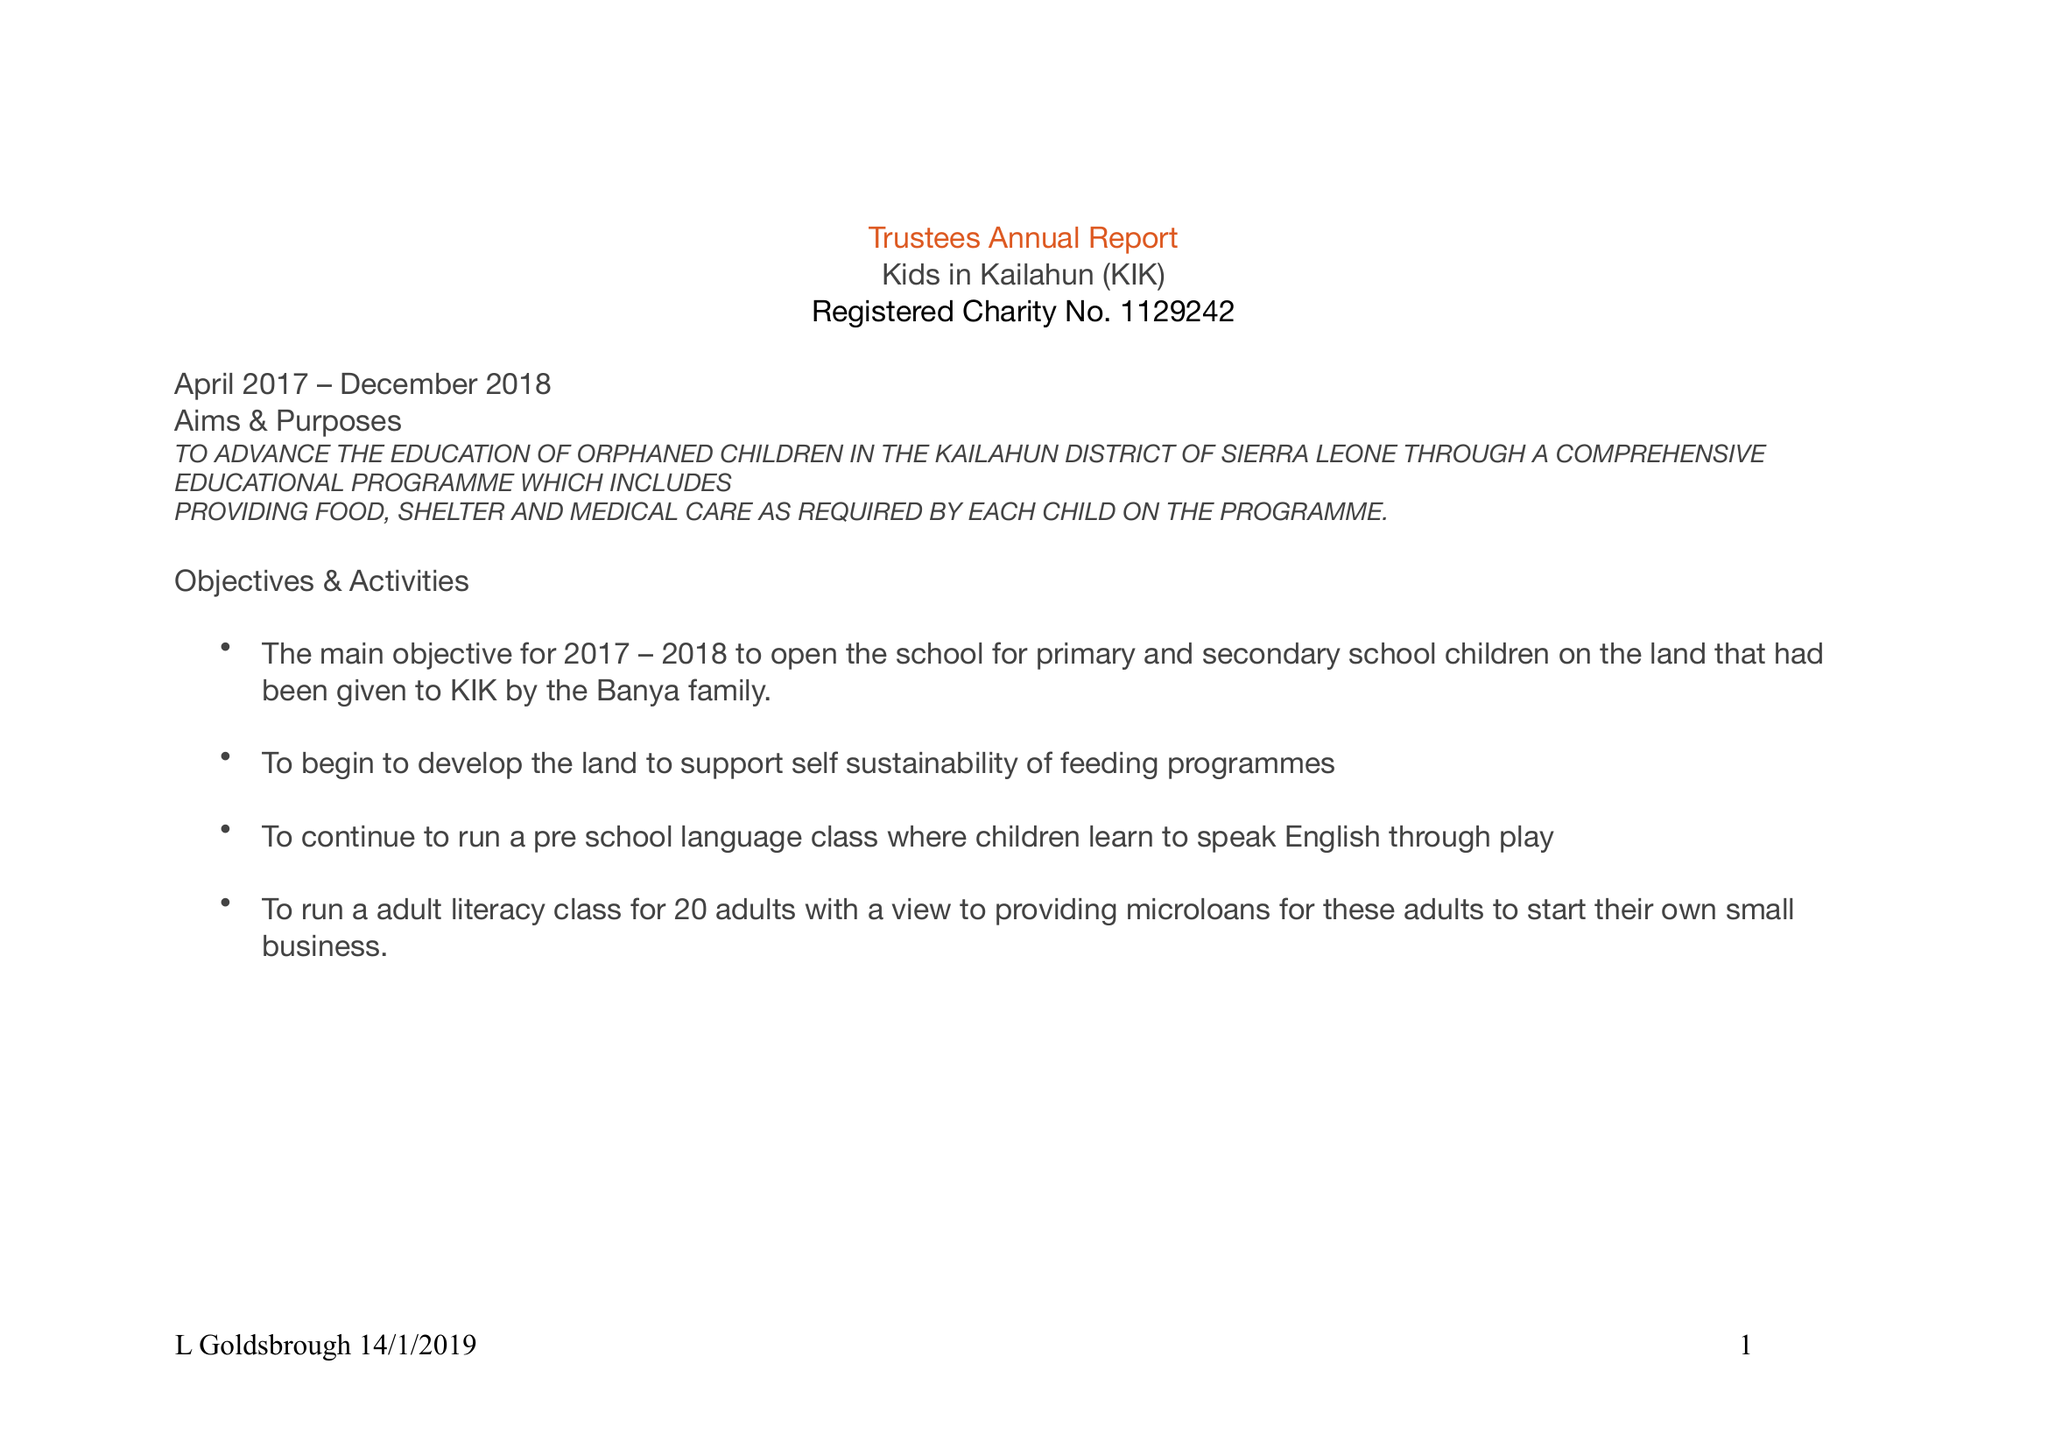What is the value for the income_annually_in_british_pounds?
Answer the question using a single word or phrase. 40511.00 